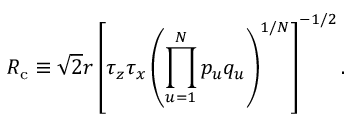Convert formula to latex. <formula><loc_0><loc_0><loc_500><loc_500>R _ { c } \equiv \sqrt { 2 } r \left [ \tau _ { z } \tau _ { x } \left ( \prod _ { u = 1 } ^ { N } p _ { u } q _ { u } \right ) ^ { 1 / N } \right ] ^ { - 1 / 2 } .</formula> 